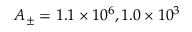<formula> <loc_0><loc_0><loc_500><loc_500>A _ { \pm } = 1 . 1 \times 1 0 ^ { 6 } , 1 . 0 \times 1 0 ^ { 3 }</formula> 